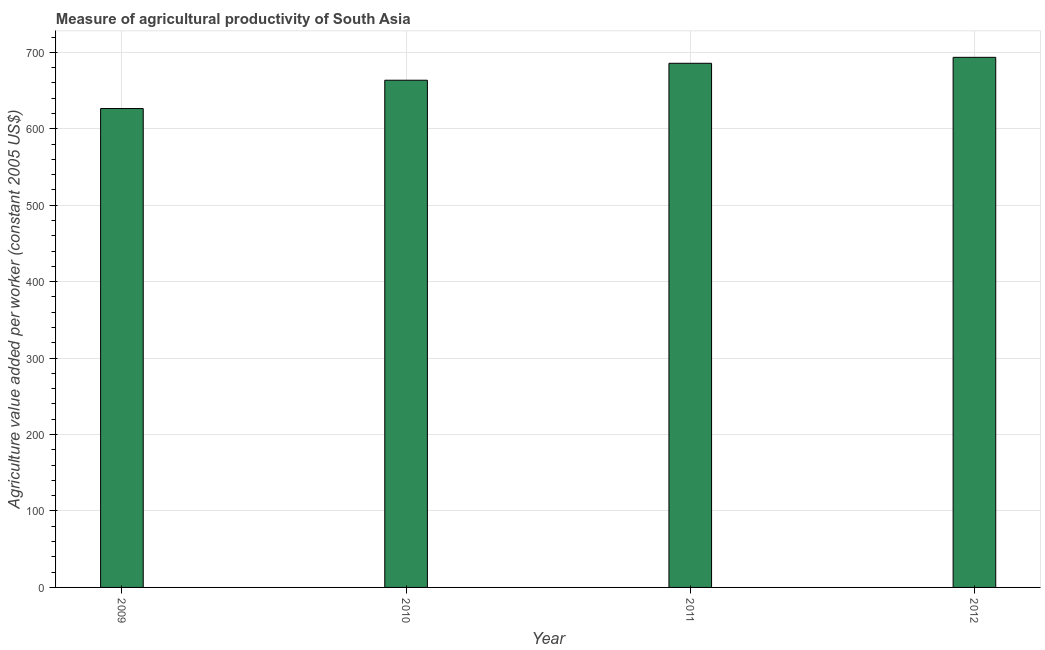Does the graph contain any zero values?
Offer a very short reply. No. Does the graph contain grids?
Your answer should be very brief. Yes. What is the title of the graph?
Offer a very short reply. Measure of agricultural productivity of South Asia. What is the label or title of the Y-axis?
Give a very brief answer. Agriculture value added per worker (constant 2005 US$). What is the agriculture value added per worker in 2009?
Offer a very short reply. 626.57. Across all years, what is the maximum agriculture value added per worker?
Ensure brevity in your answer.  693.58. Across all years, what is the minimum agriculture value added per worker?
Provide a short and direct response. 626.57. In which year was the agriculture value added per worker maximum?
Make the answer very short. 2012. What is the sum of the agriculture value added per worker?
Offer a very short reply. 2669.54. What is the difference between the agriculture value added per worker in 2011 and 2012?
Keep it short and to the point. -7.8. What is the average agriculture value added per worker per year?
Give a very brief answer. 667.39. What is the median agriculture value added per worker?
Provide a succinct answer. 674.7. In how many years, is the agriculture value added per worker greater than 360 US$?
Ensure brevity in your answer.  4. Do a majority of the years between 2009 and 2011 (inclusive) have agriculture value added per worker greater than 520 US$?
Your answer should be compact. Yes. What is the ratio of the agriculture value added per worker in 2009 to that in 2010?
Give a very brief answer. 0.94. Is the agriculture value added per worker in 2009 less than that in 2010?
Give a very brief answer. Yes. What is the difference between the highest and the second highest agriculture value added per worker?
Your answer should be very brief. 7.8. What is the difference between the highest and the lowest agriculture value added per worker?
Ensure brevity in your answer.  67.01. What is the difference between two consecutive major ticks on the Y-axis?
Give a very brief answer. 100. What is the Agriculture value added per worker (constant 2005 US$) in 2009?
Provide a short and direct response. 626.57. What is the Agriculture value added per worker (constant 2005 US$) of 2010?
Offer a very short reply. 663.62. What is the Agriculture value added per worker (constant 2005 US$) in 2011?
Make the answer very short. 685.78. What is the Agriculture value added per worker (constant 2005 US$) of 2012?
Offer a terse response. 693.58. What is the difference between the Agriculture value added per worker (constant 2005 US$) in 2009 and 2010?
Give a very brief answer. -37.05. What is the difference between the Agriculture value added per worker (constant 2005 US$) in 2009 and 2011?
Ensure brevity in your answer.  -59.21. What is the difference between the Agriculture value added per worker (constant 2005 US$) in 2009 and 2012?
Your answer should be very brief. -67.01. What is the difference between the Agriculture value added per worker (constant 2005 US$) in 2010 and 2011?
Give a very brief answer. -22.16. What is the difference between the Agriculture value added per worker (constant 2005 US$) in 2010 and 2012?
Give a very brief answer. -29.96. What is the difference between the Agriculture value added per worker (constant 2005 US$) in 2011 and 2012?
Make the answer very short. -7.8. What is the ratio of the Agriculture value added per worker (constant 2005 US$) in 2009 to that in 2010?
Your response must be concise. 0.94. What is the ratio of the Agriculture value added per worker (constant 2005 US$) in 2009 to that in 2011?
Provide a short and direct response. 0.91. What is the ratio of the Agriculture value added per worker (constant 2005 US$) in 2009 to that in 2012?
Your answer should be compact. 0.9. What is the ratio of the Agriculture value added per worker (constant 2005 US$) in 2010 to that in 2012?
Offer a terse response. 0.96. What is the ratio of the Agriculture value added per worker (constant 2005 US$) in 2011 to that in 2012?
Ensure brevity in your answer.  0.99. 